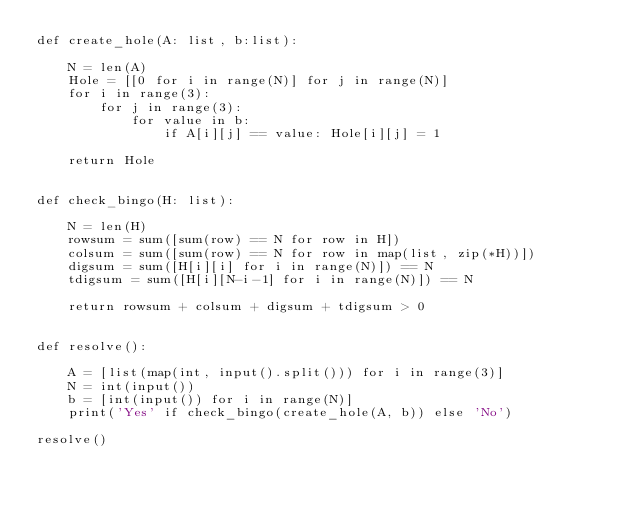<code> <loc_0><loc_0><loc_500><loc_500><_Python_>def create_hole(A: list, b:list):

    N = len(A)
    Hole = [[0 for i in range(N)] for j in range(N)]
    for i in range(3):
        for j in range(3):
            for value in b:
                if A[i][j] == value: Hole[i][j] = 1

    return Hole


def check_bingo(H: list):

    N = len(H)
    rowsum = sum([sum(row) == N for row in H])
    colsum = sum([sum(row) == N for row in map(list, zip(*H))])
    digsum = sum([H[i][i] for i in range(N)]) == N
    tdigsum = sum([H[i][N-i-1] for i in range(N)]) == N

    return rowsum + colsum + digsum + tdigsum > 0


def resolve():

    A = [list(map(int, input().split())) for i in range(3)]
    N = int(input())
    b = [int(input()) for i in range(N)]
    print('Yes' if check_bingo(create_hole(A, b)) else 'No')
    
resolve()</code> 